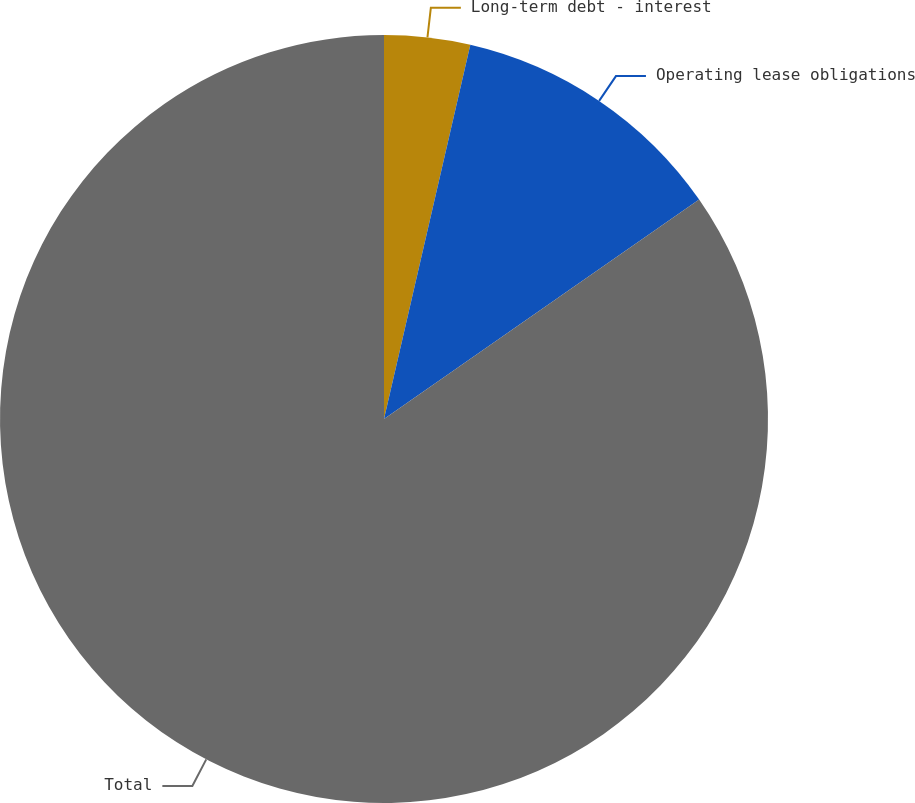<chart> <loc_0><loc_0><loc_500><loc_500><pie_chart><fcel>Long-term debt - interest<fcel>Operating lease obligations<fcel>Total<nl><fcel>3.61%<fcel>11.71%<fcel>84.68%<nl></chart> 